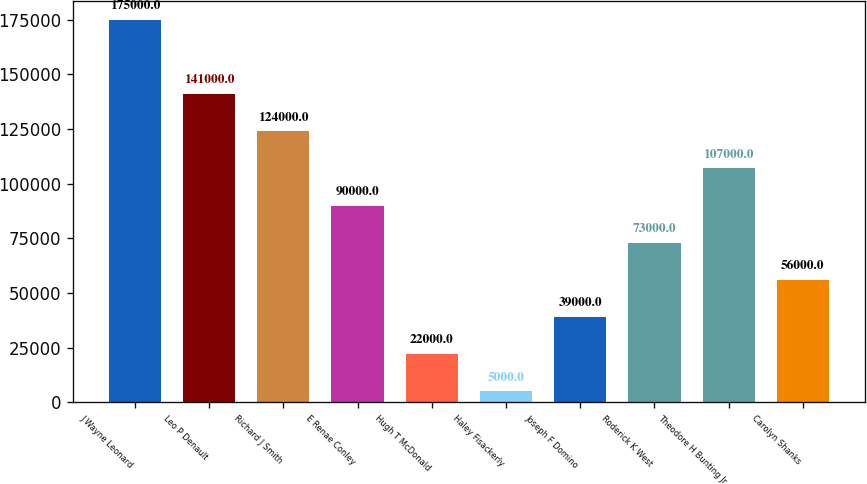Convert chart. <chart><loc_0><loc_0><loc_500><loc_500><bar_chart><fcel>J Wayne Leonard<fcel>Leo P Denault<fcel>Richard J Smith<fcel>E Renae Conley<fcel>Hugh T McDonald<fcel>Haley Fisackerly<fcel>Joseph F Domino<fcel>Roderick K West<fcel>Theodore H Bunting Jr<fcel>Carolyn Shanks<nl><fcel>175000<fcel>141000<fcel>124000<fcel>90000<fcel>22000<fcel>5000<fcel>39000<fcel>73000<fcel>107000<fcel>56000<nl></chart> 